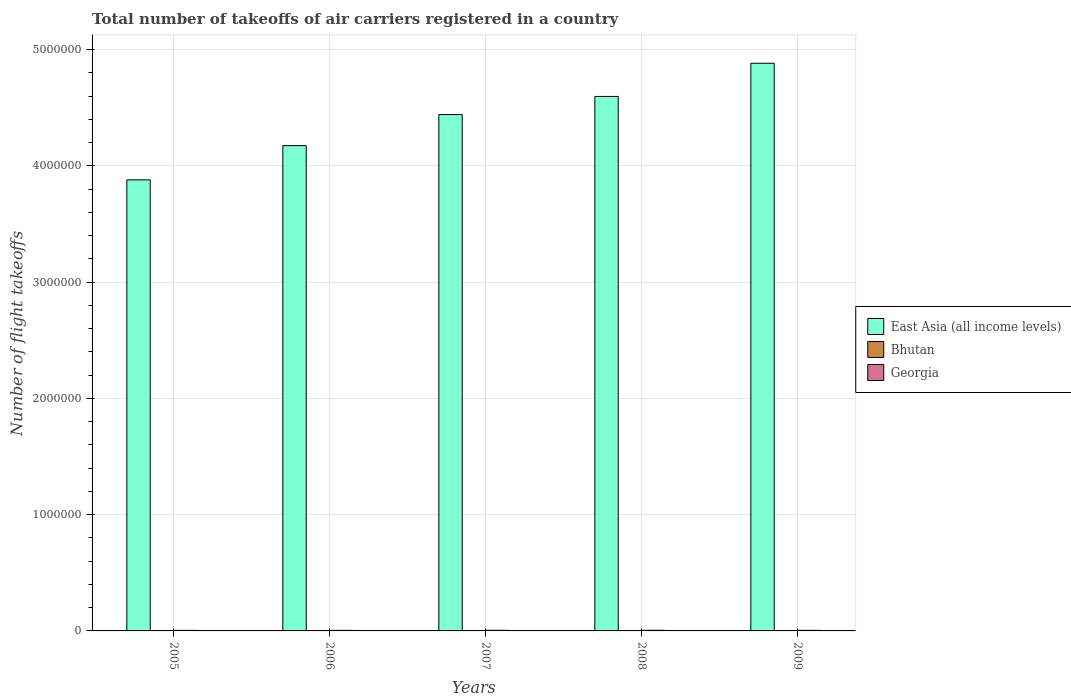How many different coloured bars are there?
Ensure brevity in your answer.  3. Are the number of bars per tick equal to the number of legend labels?
Provide a succinct answer. Yes. Are the number of bars on each tick of the X-axis equal?
Offer a terse response. Yes. What is the label of the 1st group of bars from the left?
Keep it short and to the point. 2005. In how many cases, is the number of bars for a given year not equal to the number of legend labels?
Offer a very short reply. 0. What is the total number of flight takeoffs in Bhutan in 2006?
Offer a very short reply. 2566. Across all years, what is the maximum total number of flight takeoffs in Georgia?
Your answer should be very brief. 5487. Across all years, what is the minimum total number of flight takeoffs in Georgia?
Provide a short and direct response. 4673. In which year was the total number of flight takeoffs in East Asia (all income levels) minimum?
Offer a very short reply. 2005. What is the total total number of flight takeoffs in Georgia in the graph?
Offer a very short reply. 2.54e+04. What is the difference between the total number of flight takeoffs in Georgia in 2005 and that in 2008?
Your answer should be compact. -814. What is the difference between the total number of flight takeoffs in Bhutan in 2009 and the total number of flight takeoffs in East Asia (all income levels) in 2006?
Keep it short and to the point. -4.17e+06. What is the average total number of flight takeoffs in Georgia per year?
Give a very brief answer. 5084.4. In the year 2009, what is the difference between the total number of flight takeoffs in East Asia (all income levels) and total number of flight takeoffs in Georgia?
Your response must be concise. 4.88e+06. In how many years, is the total number of flight takeoffs in Georgia greater than 3600000?
Ensure brevity in your answer.  0. What is the ratio of the total number of flight takeoffs in Georgia in 2005 to that in 2009?
Your answer should be very brief. 0.92. What is the difference between the highest and the second highest total number of flight takeoffs in East Asia (all income levels)?
Offer a very short reply. 2.85e+05. What is the difference between the highest and the lowest total number of flight takeoffs in East Asia (all income levels)?
Make the answer very short. 1.00e+06. What does the 1st bar from the left in 2006 represents?
Provide a succinct answer. East Asia (all income levels). What does the 3rd bar from the right in 2005 represents?
Your answer should be compact. East Asia (all income levels). Is it the case that in every year, the sum of the total number of flight takeoffs in Bhutan and total number of flight takeoffs in East Asia (all income levels) is greater than the total number of flight takeoffs in Georgia?
Keep it short and to the point. Yes. How many bars are there?
Keep it short and to the point. 15. Are all the bars in the graph horizontal?
Your answer should be compact. No. How many years are there in the graph?
Offer a very short reply. 5. What is the difference between two consecutive major ticks on the Y-axis?
Offer a very short reply. 1.00e+06. Are the values on the major ticks of Y-axis written in scientific E-notation?
Offer a terse response. No. Does the graph contain any zero values?
Offer a terse response. No. Does the graph contain grids?
Provide a succinct answer. Yes. How many legend labels are there?
Offer a very short reply. 3. How are the legend labels stacked?
Keep it short and to the point. Vertical. What is the title of the graph?
Give a very brief answer. Total number of takeoffs of air carriers registered in a country. What is the label or title of the X-axis?
Provide a succinct answer. Years. What is the label or title of the Y-axis?
Your response must be concise. Number of flight takeoffs. What is the Number of flight takeoffs in East Asia (all income levels) in 2005?
Provide a succinct answer. 3.88e+06. What is the Number of flight takeoffs in Bhutan in 2005?
Give a very brief answer. 2467. What is the Number of flight takeoffs in Georgia in 2005?
Offer a very short reply. 4673. What is the Number of flight takeoffs in East Asia (all income levels) in 2006?
Keep it short and to the point. 4.17e+06. What is the Number of flight takeoffs in Bhutan in 2006?
Make the answer very short. 2566. What is the Number of flight takeoffs of Georgia in 2006?
Give a very brief answer. 4861. What is the Number of flight takeoffs of East Asia (all income levels) in 2007?
Provide a short and direct response. 4.44e+06. What is the Number of flight takeoffs of Bhutan in 2007?
Make the answer very short. 2720. What is the Number of flight takeoffs of Georgia in 2007?
Your answer should be compact. 5347. What is the Number of flight takeoffs of East Asia (all income levels) in 2008?
Give a very brief answer. 4.60e+06. What is the Number of flight takeoffs of Bhutan in 2008?
Make the answer very short. 2772. What is the Number of flight takeoffs in Georgia in 2008?
Make the answer very short. 5487. What is the Number of flight takeoffs of East Asia (all income levels) in 2009?
Make the answer very short. 4.88e+06. What is the Number of flight takeoffs of Bhutan in 2009?
Make the answer very short. 2706. What is the Number of flight takeoffs of Georgia in 2009?
Keep it short and to the point. 5054. Across all years, what is the maximum Number of flight takeoffs of East Asia (all income levels)?
Provide a succinct answer. 4.88e+06. Across all years, what is the maximum Number of flight takeoffs in Bhutan?
Provide a short and direct response. 2772. Across all years, what is the maximum Number of flight takeoffs of Georgia?
Your response must be concise. 5487. Across all years, what is the minimum Number of flight takeoffs of East Asia (all income levels)?
Ensure brevity in your answer.  3.88e+06. Across all years, what is the minimum Number of flight takeoffs of Bhutan?
Ensure brevity in your answer.  2467. Across all years, what is the minimum Number of flight takeoffs in Georgia?
Offer a very short reply. 4673. What is the total Number of flight takeoffs of East Asia (all income levels) in the graph?
Your answer should be compact. 2.20e+07. What is the total Number of flight takeoffs of Bhutan in the graph?
Give a very brief answer. 1.32e+04. What is the total Number of flight takeoffs in Georgia in the graph?
Your answer should be compact. 2.54e+04. What is the difference between the Number of flight takeoffs of East Asia (all income levels) in 2005 and that in 2006?
Make the answer very short. -2.95e+05. What is the difference between the Number of flight takeoffs in Bhutan in 2005 and that in 2006?
Your response must be concise. -99. What is the difference between the Number of flight takeoffs of Georgia in 2005 and that in 2006?
Your answer should be compact. -188. What is the difference between the Number of flight takeoffs in East Asia (all income levels) in 2005 and that in 2007?
Offer a very short reply. -5.62e+05. What is the difference between the Number of flight takeoffs of Bhutan in 2005 and that in 2007?
Ensure brevity in your answer.  -253. What is the difference between the Number of flight takeoffs in Georgia in 2005 and that in 2007?
Give a very brief answer. -674. What is the difference between the Number of flight takeoffs in East Asia (all income levels) in 2005 and that in 2008?
Your answer should be compact. -7.18e+05. What is the difference between the Number of flight takeoffs of Bhutan in 2005 and that in 2008?
Ensure brevity in your answer.  -305. What is the difference between the Number of flight takeoffs of Georgia in 2005 and that in 2008?
Keep it short and to the point. -814. What is the difference between the Number of flight takeoffs in East Asia (all income levels) in 2005 and that in 2009?
Keep it short and to the point. -1.00e+06. What is the difference between the Number of flight takeoffs of Bhutan in 2005 and that in 2009?
Offer a terse response. -239. What is the difference between the Number of flight takeoffs in Georgia in 2005 and that in 2009?
Your answer should be very brief. -381. What is the difference between the Number of flight takeoffs of East Asia (all income levels) in 2006 and that in 2007?
Provide a succinct answer. -2.67e+05. What is the difference between the Number of flight takeoffs in Bhutan in 2006 and that in 2007?
Provide a short and direct response. -154. What is the difference between the Number of flight takeoffs of Georgia in 2006 and that in 2007?
Your answer should be compact. -486. What is the difference between the Number of flight takeoffs of East Asia (all income levels) in 2006 and that in 2008?
Keep it short and to the point. -4.23e+05. What is the difference between the Number of flight takeoffs of Bhutan in 2006 and that in 2008?
Your answer should be compact. -206. What is the difference between the Number of flight takeoffs of Georgia in 2006 and that in 2008?
Your response must be concise. -626. What is the difference between the Number of flight takeoffs of East Asia (all income levels) in 2006 and that in 2009?
Ensure brevity in your answer.  -7.09e+05. What is the difference between the Number of flight takeoffs of Bhutan in 2006 and that in 2009?
Offer a very short reply. -140. What is the difference between the Number of flight takeoffs of Georgia in 2006 and that in 2009?
Provide a short and direct response. -193. What is the difference between the Number of flight takeoffs in East Asia (all income levels) in 2007 and that in 2008?
Keep it short and to the point. -1.56e+05. What is the difference between the Number of flight takeoffs in Bhutan in 2007 and that in 2008?
Your answer should be very brief. -52. What is the difference between the Number of flight takeoffs of Georgia in 2007 and that in 2008?
Offer a very short reply. -140. What is the difference between the Number of flight takeoffs of East Asia (all income levels) in 2007 and that in 2009?
Your answer should be compact. -4.41e+05. What is the difference between the Number of flight takeoffs in Bhutan in 2007 and that in 2009?
Your answer should be very brief. 14. What is the difference between the Number of flight takeoffs of Georgia in 2007 and that in 2009?
Offer a very short reply. 293. What is the difference between the Number of flight takeoffs of East Asia (all income levels) in 2008 and that in 2009?
Your answer should be very brief. -2.85e+05. What is the difference between the Number of flight takeoffs in Georgia in 2008 and that in 2009?
Make the answer very short. 433. What is the difference between the Number of flight takeoffs in East Asia (all income levels) in 2005 and the Number of flight takeoffs in Bhutan in 2006?
Give a very brief answer. 3.88e+06. What is the difference between the Number of flight takeoffs of East Asia (all income levels) in 2005 and the Number of flight takeoffs of Georgia in 2006?
Provide a succinct answer. 3.88e+06. What is the difference between the Number of flight takeoffs in Bhutan in 2005 and the Number of flight takeoffs in Georgia in 2006?
Your response must be concise. -2394. What is the difference between the Number of flight takeoffs of East Asia (all income levels) in 2005 and the Number of flight takeoffs of Bhutan in 2007?
Provide a short and direct response. 3.88e+06. What is the difference between the Number of flight takeoffs of East Asia (all income levels) in 2005 and the Number of flight takeoffs of Georgia in 2007?
Give a very brief answer. 3.87e+06. What is the difference between the Number of flight takeoffs of Bhutan in 2005 and the Number of flight takeoffs of Georgia in 2007?
Provide a succinct answer. -2880. What is the difference between the Number of flight takeoffs of East Asia (all income levels) in 2005 and the Number of flight takeoffs of Bhutan in 2008?
Give a very brief answer. 3.88e+06. What is the difference between the Number of flight takeoffs of East Asia (all income levels) in 2005 and the Number of flight takeoffs of Georgia in 2008?
Provide a short and direct response. 3.87e+06. What is the difference between the Number of flight takeoffs in Bhutan in 2005 and the Number of flight takeoffs in Georgia in 2008?
Your answer should be very brief. -3020. What is the difference between the Number of flight takeoffs of East Asia (all income levels) in 2005 and the Number of flight takeoffs of Bhutan in 2009?
Keep it short and to the point. 3.88e+06. What is the difference between the Number of flight takeoffs in East Asia (all income levels) in 2005 and the Number of flight takeoffs in Georgia in 2009?
Keep it short and to the point. 3.87e+06. What is the difference between the Number of flight takeoffs of Bhutan in 2005 and the Number of flight takeoffs of Georgia in 2009?
Provide a short and direct response. -2587. What is the difference between the Number of flight takeoffs in East Asia (all income levels) in 2006 and the Number of flight takeoffs in Bhutan in 2007?
Keep it short and to the point. 4.17e+06. What is the difference between the Number of flight takeoffs of East Asia (all income levels) in 2006 and the Number of flight takeoffs of Georgia in 2007?
Your response must be concise. 4.17e+06. What is the difference between the Number of flight takeoffs in Bhutan in 2006 and the Number of flight takeoffs in Georgia in 2007?
Your response must be concise. -2781. What is the difference between the Number of flight takeoffs in East Asia (all income levels) in 2006 and the Number of flight takeoffs in Bhutan in 2008?
Ensure brevity in your answer.  4.17e+06. What is the difference between the Number of flight takeoffs of East Asia (all income levels) in 2006 and the Number of flight takeoffs of Georgia in 2008?
Your answer should be compact. 4.17e+06. What is the difference between the Number of flight takeoffs in Bhutan in 2006 and the Number of flight takeoffs in Georgia in 2008?
Your answer should be very brief. -2921. What is the difference between the Number of flight takeoffs of East Asia (all income levels) in 2006 and the Number of flight takeoffs of Bhutan in 2009?
Ensure brevity in your answer.  4.17e+06. What is the difference between the Number of flight takeoffs of East Asia (all income levels) in 2006 and the Number of flight takeoffs of Georgia in 2009?
Keep it short and to the point. 4.17e+06. What is the difference between the Number of flight takeoffs of Bhutan in 2006 and the Number of flight takeoffs of Georgia in 2009?
Provide a short and direct response. -2488. What is the difference between the Number of flight takeoffs in East Asia (all income levels) in 2007 and the Number of flight takeoffs in Bhutan in 2008?
Make the answer very short. 4.44e+06. What is the difference between the Number of flight takeoffs in East Asia (all income levels) in 2007 and the Number of flight takeoffs in Georgia in 2008?
Offer a terse response. 4.44e+06. What is the difference between the Number of flight takeoffs of Bhutan in 2007 and the Number of flight takeoffs of Georgia in 2008?
Make the answer very short. -2767. What is the difference between the Number of flight takeoffs of East Asia (all income levels) in 2007 and the Number of flight takeoffs of Bhutan in 2009?
Ensure brevity in your answer.  4.44e+06. What is the difference between the Number of flight takeoffs in East Asia (all income levels) in 2007 and the Number of flight takeoffs in Georgia in 2009?
Give a very brief answer. 4.44e+06. What is the difference between the Number of flight takeoffs of Bhutan in 2007 and the Number of flight takeoffs of Georgia in 2009?
Ensure brevity in your answer.  -2334. What is the difference between the Number of flight takeoffs in East Asia (all income levels) in 2008 and the Number of flight takeoffs in Bhutan in 2009?
Make the answer very short. 4.59e+06. What is the difference between the Number of flight takeoffs in East Asia (all income levels) in 2008 and the Number of flight takeoffs in Georgia in 2009?
Provide a succinct answer. 4.59e+06. What is the difference between the Number of flight takeoffs of Bhutan in 2008 and the Number of flight takeoffs of Georgia in 2009?
Your answer should be compact. -2282. What is the average Number of flight takeoffs of East Asia (all income levels) per year?
Offer a terse response. 4.40e+06. What is the average Number of flight takeoffs of Bhutan per year?
Offer a very short reply. 2646.2. What is the average Number of flight takeoffs in Georgia per year?
Your answer should be compact. 5084.4. In the year 2005, what is the difference between the Number of flight takeoffs of East Asia (all income levels) and Number of flight takeoffs of Bhutan?
Ensure brevity in your answer.  3.88e+06. In the year 2005, what is the difference between the Number of flight takeoffs in East Asia (all income levels) and Number of flight takeoffs in Georgia?
Your answer should be compact. 3.88e+06. In the year 2005, what is the difference between the Number of flight takeoffs of Bhutan and Number of flight takeoffs of Georgia?
Your answer should be very brief. -2206. In the year 2006, what is the difference between the Number of flight takeoffs in East Asia (all income levels) and Number of flight takeoffs in Bhutan?
Offer a terse response. 4.17e+06. In the year 2006, what is the difference between the Number of flight takeoffs in East Asia (all income levels) and Number of flight takeoffs in Georgia?
Offer a terse response. 4.17e+06. In the year 2006, what is the difference between the Number of flight takeoffs of Bhutan and Number of flight takeoffs of Georgia?
Give a very brief answer. -2295. In the year 2007, what is the difference between the Number of flight takeoffs of East Asia (all income levels) and Number of flight takeoffs of Bhutan?
Ensure brevity in your answer.  4.44e+06. In the year 2007, what is the difference between the Number of flight takeoffs in East Asia (all income levels) and Number of flight takeoffs in Georgia?
Provide a short and direct response. 4.44e+06. In the year 2007, what is the difference between the Number of flight takeoffs in Bhutan and Number of flight takeoffs in Georgia?
Ensure brevity in your answer.  -2627. In the year 2008, what is the difference between the Number of flight takeoffs in East Asia (all income levels) and Number of flight takeoffs in Bhutan?
Your response must be concise. 4.59e+06. In the year 2008, what is the difference between the Number of flight takeoffs in East Asia (all income levels) and Number of flight takeoffs in Georgia?
Keep it short and to the point. 4.59e+06. In the year 2008, what is the difference between the Number of flight takeoffs of Bhutan and Number of flight takeoffs of Georgia?
Your answer should be compact. -2715. In the year 2009, what is the difference between the Number of flight takeoffs of East Asia (all income levels) and Number of flight takeoffs of Bhutan?
Your response must be concise. 4.88e+06. In the year 2009, what is the difference between the Number of flight takeoffs in East Asia (all income levels) and Number of flight takeoffs in Georgia?
Make the answer very short. 4.88e+06. In the year 2009, what is the difference between the Number of flight takeoffs in Bhutan and Number of flight takeoffs in Georgia?
Your response must be concise. -2348. What is the ratio of the Number of flight takeoffs in East Asia (all income levels) in 2005 to that in 2006?
Give a very brief answer. 0.93. What is the ratio of the Number of flight takeoffs in Bhutan in 2005 to that in 2006?
Your response must be concise. 0.96. What is the ratio of the Number of flight takeoffs in Georgia in 2005 to that in 2006?
Provide a succinct answer. 0.96. What is the ratio of the Number of flight takeoffs of East Asia (all income levels) in 2005 to that in 2007?
Your response must be concise. 0.87. What is the ratio of the Number of flight takeoffs of Bhutan in 2005 to that in 2007?
Provide a short and direct response. 0.91. What is the ratio of the Number of flight takeoffs in Georgia in 2005 to that in 2007?
Your response must be concise. 0.87. What is the ratio of the Number of flight takeoffs in East Asia (all income levels) in 2005 to that in 2008?
Provide a short and direct response. 0.84. What is the ratio of the Number of flight takeoffs in Bhutan in 2005 to that in 2008?
Provide a succinct answer. 0.89. What is the ratio of the Number of flight takeoffs of Georgia in 2005 to that in 2008?
Keep it short and to the point. 0.85. What is the ratio of the Number of flight takeoffs in East Asia (all income levels) in 2005 to that in 2009?
Offer a terse response. 0.79. What is the ratio of the Number of flight takeoffs in Bhutan in 2005 to that in 2009?
Provide a short and direct response. 0.91. What is the ratio of the Number of flight takeoffs of Georgia in 2005 to that in 2009?
Your response must be concise. 0.92. What is the ratio of the Number of flight takeoffs in East Asia (all income levels) in 2006 to that in 2007?
Your response must be concise. 0.94. What is the ratio of the Number of flight takeoffs in Bhutan in 2006 to that in 2007?
Provide a short and direct response. 0.94. What is the ratio of the Number of flight takeoffs in East Asia (all income levels) in 2006 to that in 2008?
Keep it short and to the point. 0.91. What is the ratio of the Number of flight takeoffs of Bhutan in 2006 to that in 2008?
Provide a short and direct response. 0.93. What is the ratio of the Number of flight takeoffs in Georgia in 2006 to that in 2008?
Provide a succinct answer. 0.89. What is the ratio of the Number of flight takeoffs in East Asia (all income levels) in 2006 to that in 2009?
Make the answer very short. 0.85. What is the ratio of the Number of flight takeoffs in Bhutan in 2006 to that in 2009?
Your answer should be compact. 0.95. What is the ratio of the Number of flight takeoffs in Georgia in 2006 to that in 2009?
Offer a very short reply. 0.96. What is the ratio of the Number of flight takeoffs of East Asia (all income levels) in 2007 to that in 2008?
Provide a succinct answer. 0.97. What is the ratio of the Number of flight takeoffs of Bhutan in 2007 to that in 2008?
Ensure brevity in your answer.  0.98. What is the ratio of the Number of flight takeoffs in Georgia in 2007 to that in 2008?
Your answer should be very brief. 0.97. What is the ratio of the Number of flight takeoffs of East Asia (all income levels) in 2007 to that in 2009?
Give a very brief answer. 0.91. What is the ratio of the Number of flight takeoffs of Georgia in 2007 to that in 2009?
Your response must be concise. 1.06. What is the ratio of the Number of flight takeoffs in East Asia (all income levels) in 2008 to that in 2009?
Offer a terse response. 0.94. What is the ratio of the Number of flight takeoffs of Bhutan in 2008 to that in 2009?
Provide a succinct answer. 1.02. What is the ratio of the Number of flight takeoffs of Georgia in 2008 to that in 2009?
Your answer should be very brief. 1.09. What is the difference between the highest and the second highest Number of flight takeoffs of East Asia (all income levels)?
Give a very brief answer. 2.85e+05. What is the difference between the highest and the second highest Number of flight takeoffs of Georgia?
Keep it short and to the point. 140. What is the difference between the highest and the lowest Number of flight takeoffs in East Asia (all income levels)?
Your response must be concise. 1.00e+06. What is the difference between the highest and the lowest Number of flight takeoffs in Bhutan?
Offer a very short reply. 305. What is the difference between the highest and the lowest Number of flight takeoffs in Georgia?
Make the answer very short. 814. 